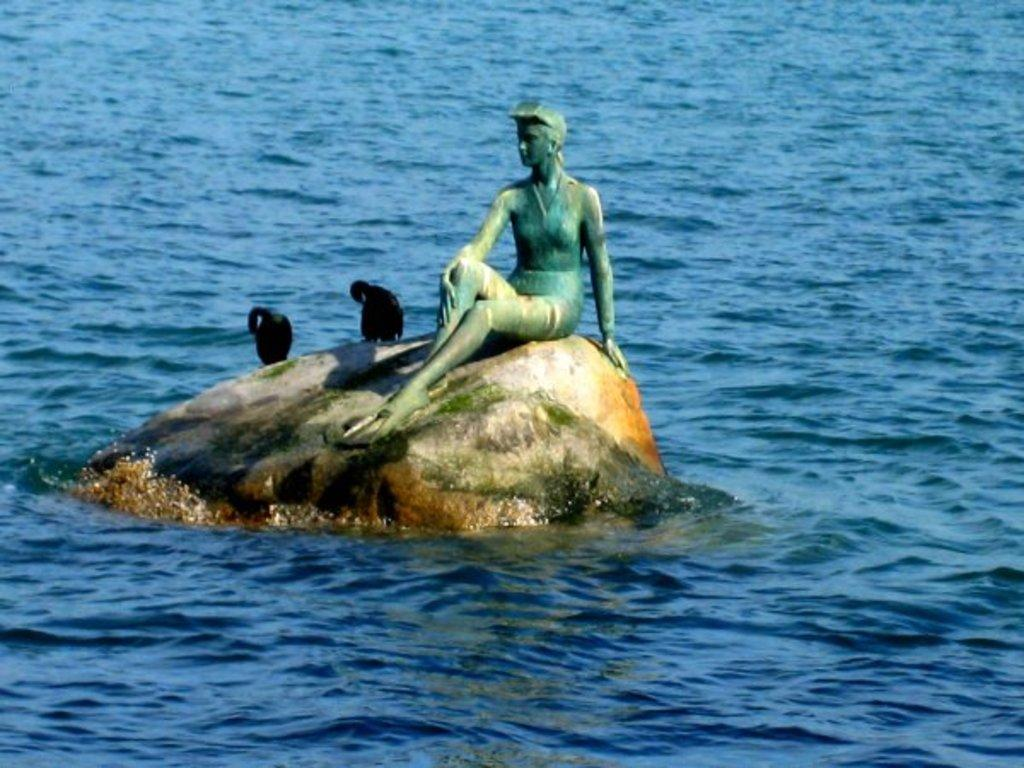What is the main subject in the center of the image? There is a statue in the center of the image. What other living creatures can be seen in the image? There are birds on a rock in the image. What can be seen in the background of the image? There is water visible in the background of the image. How many laborers are pushing the statue in the image? There are no laborers present in the image, nor is the statue being pushed. 